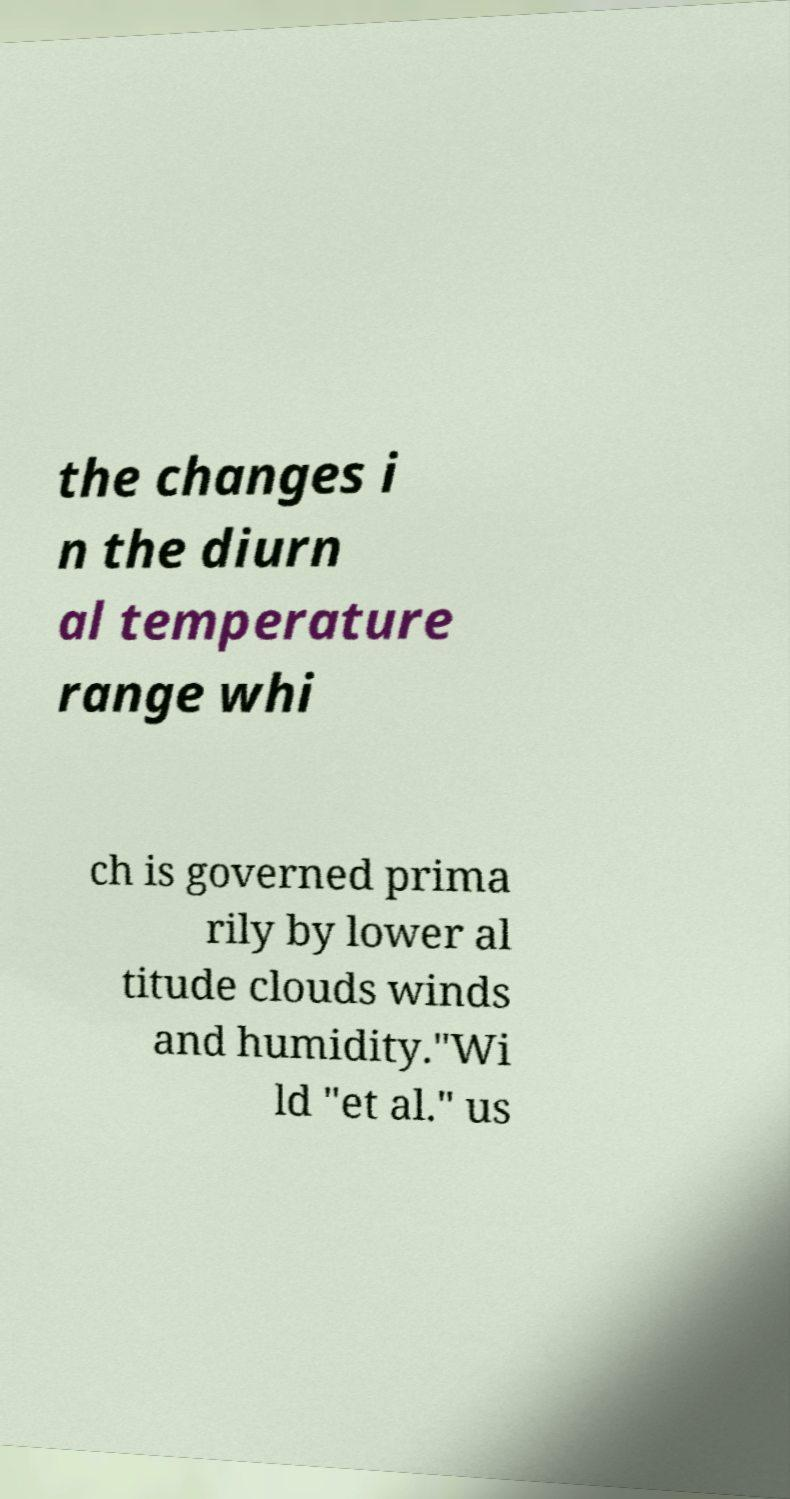Could you extract and type out the text from this image? the changes i n the diurn al temperature range whi ch is governed prima rily by lower al titude clouds winds and humidity."Wi ld "et al." us 